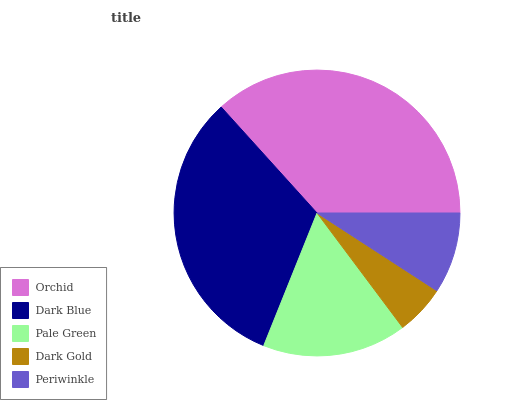Is Dark Gold the minimum?
Answer yes or no. Yes. Is Orchid the maximum?
Answer yes or no. Yes. Is Dark Blue the minimum?
Answer yes or no. No. Is Dark Blue the maximum?
Answer yes or no. No. Is Orchid greater than Dark Blue?
Answer yes or no. Yes. Is Dark Blue less than Orchid?
Answer yes or no. Yes. Is Dark Blue greater than Orchid?
Answer yes or no. No. Is Orchid less than Dark Blue?
Answer yes or no. No. Is Pale Green the high median?
Answer yes or no. Yes. Is Pale Green the low median?
Answer yes or no. Yes. Is Dark Blue the high median?
Answer yes or no. No. Is Orchid the low median?
Answer yes or no. No. 